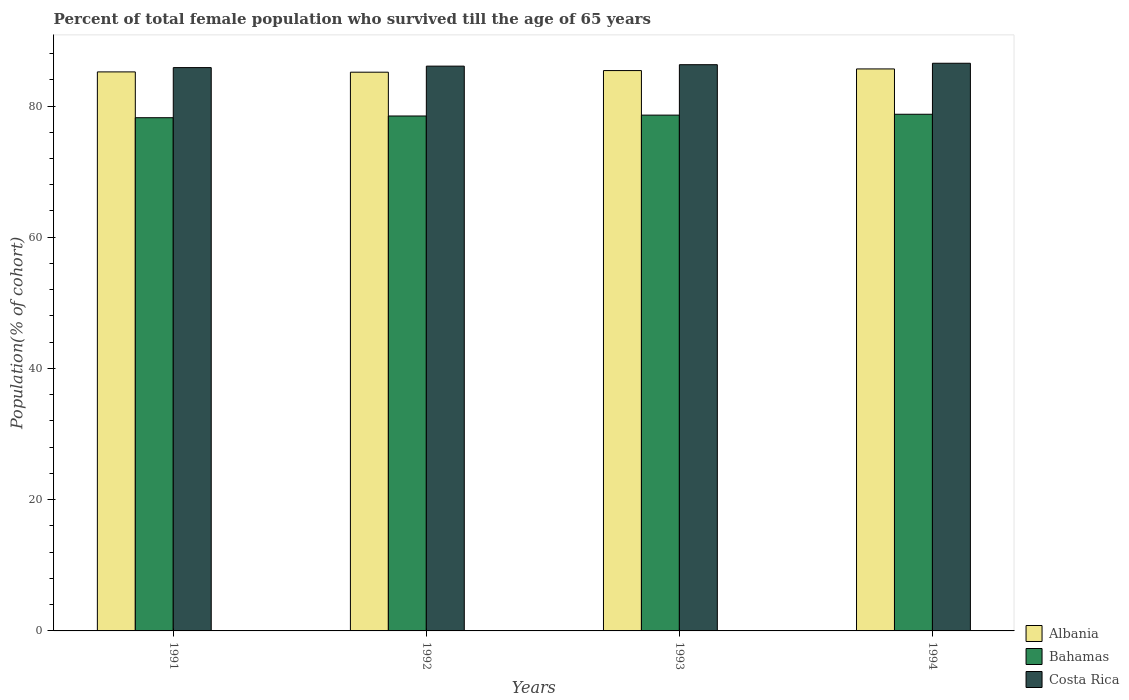How many different coloured bars are there?
Give a very brief answer. 3. Are the number of bars on each tick of the X-axis equal?
Provide a succinct answer. Yes. How many bars are there on the 1st tick from the left?
Make the answer very short. 3. How many bars are there on the 3rd tick from the right?
Keep it short and to the point. 3. What is the percentage of total female population who survived till the age of 65 years in Albania in 1993?
Offer a very short reply. 85.4. Across all years, what is the maximum percentage of total female population who survived till the age of 65 years in Bahamas?
Your answer should be compact. 78.74. Across all years, what is the minimum percentage of total female population who survived till the age of 65 years in Costa Rica?
Offer a very short reply. 85.85. In which year was the percentage of total female population who survived till the age of 65 years in Costa Rica maximum?
Offer a terse response. 1994. In which year was the percentage of total female population who survived till the age of 65 years in Albania minimum?
Make the answer very short. 1992. What is the total percentage of total female population who survived till the age of 65 years in Bahamas in the graph?
Offer a terse response. 314.05. What is the difference between the percentage of total female population who survived till the age of 65 years in Albania in 1991 and that in 1993?
Offer a terse response. -0.2. What is the difference between the percentage of total female population who survived till the age of 65 years in Albania in 1992 and the percentage of total female population who survived till the age of 65 years in Bahamas in 1991?
Make the answer very short. 6.93. What is the average percentage of total female population who survived till the age of 65 years in Albania per year?
Give a very brief answer. 85.35. In the year 1992, what is the difference between the percentage of total female population who survived till the age of 65 years in Albania and percentage of total female population who survived till the age of 65 years in Bahamas?
Keep it short and to the point. 6.67. What is the ratio of the percentage of total female population who survived till the age of 65 years in Costa Rica in 1992 to that in 1994?
Offer a terse response. 0.99. Is the percentage of total female population who survived till the age of 65 years in Bahamas in 1992 less than that in 1993?
Your response must be concise. Yes. What is the difference between the highest and the second highest percentage of total female population who survived till the age of 65 years in Bahamas?
Provide a succinct answer. 0.13. What is the difference between the highest and the lowest percentage of total female population who survived till the age of 65 years in Costa Rica?
Provide a succinct answer. 0.66. In how many years, is the percentage of total female population who survived till the age of 65 years in Costa Rica greater than the average percentage of total female population who survived till the age of 65 years in Costa Rica taken over all years?
Make the answer very short. 2. Is the sum of the percentage of total female population who survived till the age of 65 years in Bahamas in 1991 and 1993 greater than the maximum percentage of total female population who survived till the age of 65 years in Albania across all years?
Ensure brevity in your answer.  Yes. What does the 2nd bar from the left in 1991 represents?
Your answer should be very brief. Bahamas. What does the 2nd bar from the right in 1991 represents?
Make the answer very short. Bahamas. Where does the legend appear in the graph?
Make the answer very short. Bottom right. How are the legend labels stacked?
Keep it short and to the point. Vertical. What is the title of the graph?
Your answer should be compact. Percent of total female population who survived till the age of 65 years. What is the label or title of the X-axis?
Provide a short and direct response. Years. What is the label or title of the Y-axis?
Offer a terse response. Population(% of cohort). What is the Population(% of cohort) in Albania in 1991?
Your response must be concise. 85.2. What is the Population(% of cohort) in Bahamas in 1991?
Give a very brief answer. 78.22. What is the Population(% of cohort) in Costa Rica in 1991?
Give a very brief answer. 85.85. What is the Population(% of cohort) in Albania in 1992?
Your response must be concise. 85.15. What is the Population(% of cohort) of Bahamas in 1992?
Offer a very short reply. 78.48. What is the Population(% of cohort) of Costa Rica in 1992?
Keep it short and to the point. 86.08. What is the Population(% of cohort) in Albania in 1993?
Provide a succinct answer. 85.4. What is the Population(% of cohort) of Bahamas in 1993?
Your answer should be compact. 78.61. What is the Population(% of cohort) of Costa Rica in 1993?
Give a very brief answer. 86.3. What is the Population(% of cohort) of Albania in 1994?
Offer a very short reply. 85.65. What is the Population(% of cohort) in Bahamas in 1994?
Provide a succinct answer. 78.74. What is the Population(% of cohort) of Costa Rica in 1994?
Your response must be concise. 86.51. Across all years, what is the maximum Population(% of cohort) in Albania?
Your answer should be very brief. 85.65. Across all years, what is the maximum Population(% of cohort) in Bahamas?
Make the answer very short. 78.74. Across all years, what is the maximum Population(% of cohort) of Costa Rica?
Offer a terse response. 86.51. Across all years, what is the minimum Population(% of cohort) in Albania?
Provide a succinct answer. 85.15. Across all years, what is the minimum Population(% of cohort) of Bahamas?
Offer a very short reply. 78.22. Across all years, what is the minimum Population(% of cohort) of Costa Rica?
Provide a short and direct response. 85.85. What is the total Population(% of cohort) of Albania in the graph?
Offer a very short reply. 341.4. What is the total Population(% of cohort) in Bahamas in the graph?
Keep it short and to the point. 314.05. What is the total Population(% of cohort) of Costa Rica in the graph?
Your answer should be very brief. 344.74. What is the difference between the Population(% of cohort) of Albania in 1991 and that in 1992?
Offer a terse response. 0.05. What is the difference between the Population(% of cohort) in Bahamas in 1991 and that in 1992?
Your answer should be compact. -0.26. What is the difference between the Population(% of cohort) of Costa Rica in 1991 and that in 1992?
Your answer should be very brief. -0.22. What is the difference between the Population(% of cohort) of Albania in 1991 and that in 1993?
Provide a short and direct response. -0.2. What is the difference between the Population(% of cohort) of Bahamas in 1991 and that in 1993?
Your answer should be compact. -0.39. What is the difference between the Population(% of cohort) in Costa Rica in 1991 and that in 1993?
Offer a very short reply. -0.44. What is the difference between the Population(% of cohort) in Albania in 1991 and that in 1994?
Offer a very short reply. -0.45. What is the difference between the Population(% of cohort) in Bahamas in 1991 and that in 1994?
Offer a terse response. -0.53. What is the difference between the Population(% of cohort) of Costa Rica in 1991 and that in 1994?
Ensure brevity in your answer.  -0.66. What is the difference between the Population(% of cohort) in Albania in 1992 and that in 1993?
Give a very brief answer. -0.25. What is the difference between the Population(% of cohort) of Bahamas in 1992 and that in 1993?
Provide a succinct answer. -0.13. What is the difference between the Population(% of cohort) of Costa Rica in 1992 and that in 1993?
Provide a succinct answer. -0.22. What is the difference between the Population(% of cohort) in Albania in 1992 and that in 1994?
Keep it short and to the point. -0.5. What is the difference between the Population(% of cohort) in Bahamas in 1992 and that in 1994?
Make the answer very short. -0.26. What is the difference between the Population(% of cohort) in Costa Rica in 1992 and that in 1994?
Give a very brief answer. -0.44. What is the difference between the Population(% of cohort) in Albania in 1993 and that in 1994?
Give a very brief answer. -0.25. What is the difference between the Population(% of cohort) in Bahamas in 1993 and that in 1994?
Provide a short and direct response. -0.13. What is the difference between the Population(% of cohort) of Costa Rica in 1993 and that in 1994?
Ensure brevity in your answer.  -0.22. What is the difference between the Population(% of cohort) in Albania in 1991 and the Population(% of cohort) in Bahamas in 1992?
Your response must be concise. 6.72. What is the difference between the Population(% of cohort) in Albania in 1991 and the Population(% of cohort) in Costa Rica in 1992?
Your answer should be very brief. -0.88. What is the difference between the Population(% of cohort) in Bahamas in 1991 and the Population(% of cohort) in Costa Rica in 1992?
Provide a short and direct response. -7.86. What is the difference between the Population(% of cohort) of Albania in 1991 and the Population(% of cohort) of Bahamas in 1993?
Ensure brevity in your answer.  6.59. What is the difference between the Population(% of cohort) of Albania in 1991 and the Population(% of cohort) of Costa Rica in 1993?
Your answer should be compact. -1.1. What is the difference between the Population(% of cohort) of Bahamas in 1991 and the Population(% of cohort) of Costa Rica in 1993?
Offer a terse response. -8.08. What is the difference between the Population(% of cohort) in Albania in 1991 and the Population(% of cohort) in Bahamas in 1994?
Provide a short and direct response. 6.45. What is the difference between the Population(% of cohort) in Albania in 1991 and the Population(% of cohort) in Costa Rica in 1994?
Offer a very short reply. -1.32. What is the difference between the Population(% of cohort) in Bahamas in 1991 and the Population(% of cohort) in Costa Rica in 1994?
Keep it short and to the point. -8.3. What is the difference between the Population(% of cohort) in Albania in 1992 and the Population(% of cohort) in Bahamas in 1993?
Make the answer very short. 6.54. What is the difference between the Population(% of cohort) of Albania in 1992 and the Population(% of cohort) of Costa Rica in 1993?
Provide a short and direct response. -1.14. What is the difference between the Population(% of cohort) in Bahamas in 1992 and the Population(% of cohort) in Costa Rica in 1993?
Your answer should be compact. -7.82. What is the difference between the Population(% of cohort) in Albania in 1992 and the Population(% of cohort) in Bahamas in 1994?
Your answer should be very brief. 6.41. What is the difference between the Population(% of cohort) of Albania in 1992 and the Population(% of cohort) of Costa Rica in 1994?
Ensure brevity in your answer.  -1.36. What is the difference between the Population(% of cohort) in Bahamas in 1992 and the Population(% of cohort) in Costa Rica in 1994?
Your answer should be very brief. -8.04. What is the difference between the Population(% of cohort) in Albania in 1993 and the Population(% of cohort) in Bahamas in 1994?
Your answer should be compact. 6.66. What is the difference between the Population(% of cohort) in Albania in 1993 and the Population(% of cohort) in Costa Rica in 1994?
Make the answer very short. -1.11. What is the difference between the Population(% of cohort) in Bahamas in 1993 and the Population(% of cohort) in Costa Rica in 1994?
Provide a short and direct response. -7.9. What is the average Population(% of cohort) of Albania per year?
Your answer should be compact. 85.35. What is the average Population(% of cohort) in Bahamas per year?
Provide a succinct answer. 78.51. What is the average Population(% of cohort) in Costa Rica per year?
Make the answer very short. 86.18. In the year 1991, what is the difference between the Population(% of cohort) in Albania and Population(% of cohort) in Bahamas?
Your answer should be compact. 6.98. In the year 1991, what is the difference between the Population(% of cohort) in Albania and Population(% of cohort) in Costa Rica?
Provide a short and direct response. -0.66. In the year 1991, what is the difference between the Population(% of cohort) of Bahamas and Population(% of cohort) of Costa Rica?
Give a very brief answer. -7.64. In the year 1992, what is the difference between the Population(% of cohort) in Albania and Population(% of cohort) in Bahamas?
Offer a terse response. 6.67. In the year 1992, what is the difference between the Population(% of cohort) in Albania and Population(% of cohort) in Costa Rica?
Your response must be concise. -0.93. In the year 1992, what is the difference between the Population(% of cohort) in Bahamas and Population(% of cohort) in Costa Rica?
Make the answer very short. -7.6. In the year 1993, what is the difference between the Population(% of cohort) of Albania and Population(% of cohort) of Bahamas?
Offer a very short reply. 6.79. In the year 1993, what is the difference between the Population(% of cohort) of Albania and Population(% of cohort) of Costa Rica?
Your response must be concise. -0.89. In the year 1993, what is the difference between the Population(% of cohort) in Bahamas and Population(% of cohort) in Costa Rica?
Keep it short and to the point. -7.69. In the year 1994, what is the difference between the Population(% of cohort) of Albania and Population(% of cohort) of Bahamas?
Provide a short and direct response. 6.91. In the year 1994, what is the difference between the Population(% of cohort) of Albania and Population(% of cohort) of Costa Rica?
Offer a very short reply. -0.86. In the year 1994, what is the difference between the Population(% of cohort) of Bahamas and Population(% of cohort) of Costa Rica?
Offer a terse response. -7.77. What is the ratio of the Population(% of cohort) in Costa Rica in 1991 to that in 1992?
Provide a succinct answer. 1. What is the ratio of the Population(% of cohort) in Albania in 1991 to that in 1993?
Your answer should be compact. 1. What is the ratio of the Population(% of cohort) of Bahamas in 1991 to that in 1993?
Offer a terse response. 0.99. What is the ratio of the Population(% of cohort) of Costa Rica in 1991 to that in 1993?
Provide a succinct answer. 0.99. What is the ratio of the Population(% of cohort) of Costa Rica in 1991 to that in 1994?
Make the answer very short. 0.99. What is the ratio of the Population(% of cohort) in Albania in 1992 to that in 1993?
Make the answer very short. 1. What is the ratio of the Population(% of cohort) in Bahamas in 1992 to that in 1993?
Your response must be concise. 1. What is the ratio of the Population(% of cohort) of Albania in 1992 to that in 1994?
Your answer should be very brief. 0.99. What is the ratio of the Population(% of cohort) of Costa Rica in 1992 to that in 1994?
Keep it short and to the point. 0.99. What is the ratio of the Population(% of cohort) of Bahamas in 1993 to that in 1994?
Keep it short and to the point. 1. What is the difference between the highest and the second highest Population(% of cohort) in Albania?
Your response must be concise. 0.25. What is the difference between the highest and the second highest Population(% of cohort) in Bahamas?
Make the answer very short. 0.13. What is the difference between the highest and the second highest Population(% of cohort) of Costa Rica?
Give a very brief answer. 0.22. What is the difference between the highest and the lowest Population(% of cohort) in Albania?
Your answer should be very brief. 0.5. What is the difference between the highest and the lowest Population(% of cohort) of Bahamas?
Provide a short and direct response. 0.53. What is the difference between the highest and the lowest Population(% of cohort) of Costa Rica?
Ensure brevity in your answer.  0.66. 